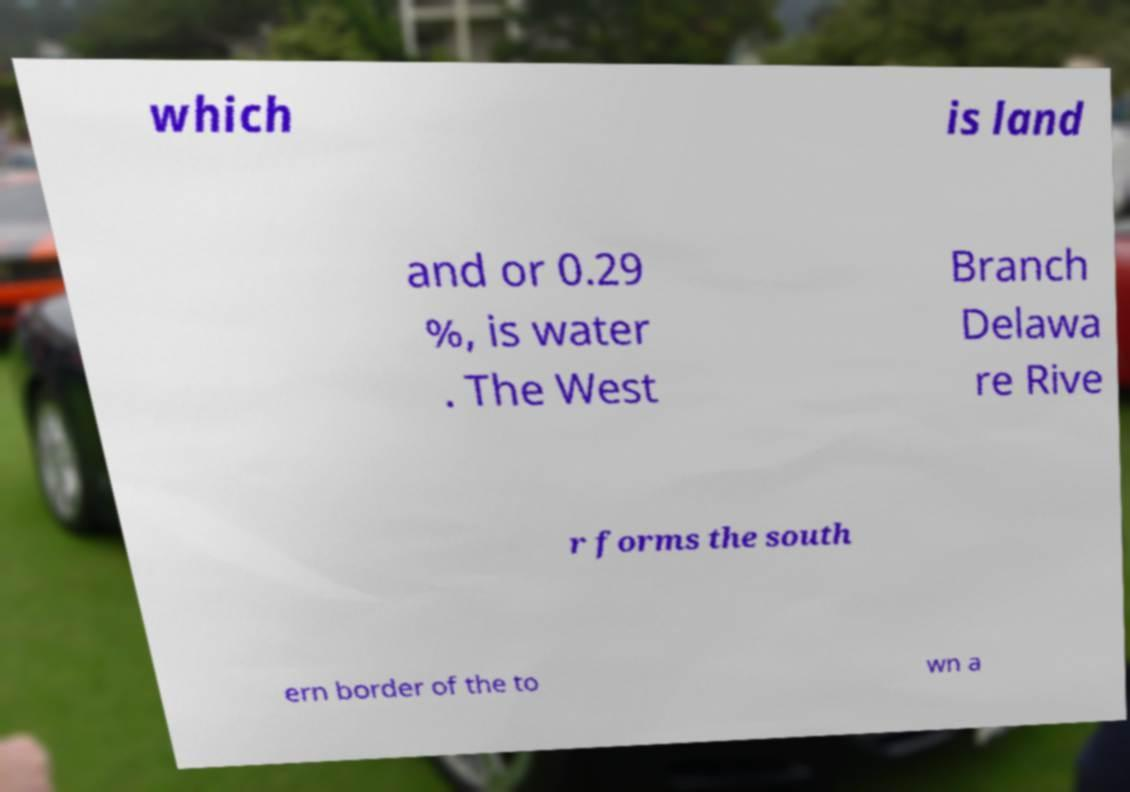Please identify and transcribe the text found in this image. which is land and or 0.29 %, is water . The West Branch Delawa re Rive r forms the south ern border of the to wn a 